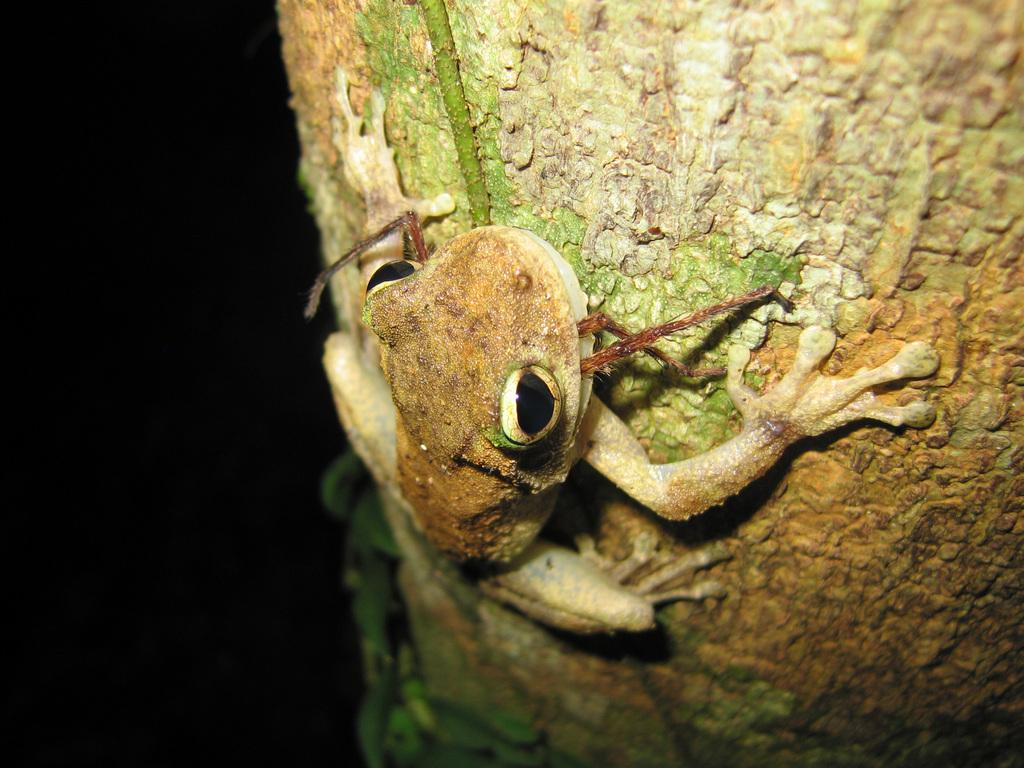What animal is present in the image? There is a frog in the image. Where is the frog located? The frog is on a tree. What part of the image does the frog occupy? The frog is in the foreground of the image. What type of rail can be seen guiding the frog's movement in the image? There is no rail present in the image, and the frog's movement is not guided by any rail. 